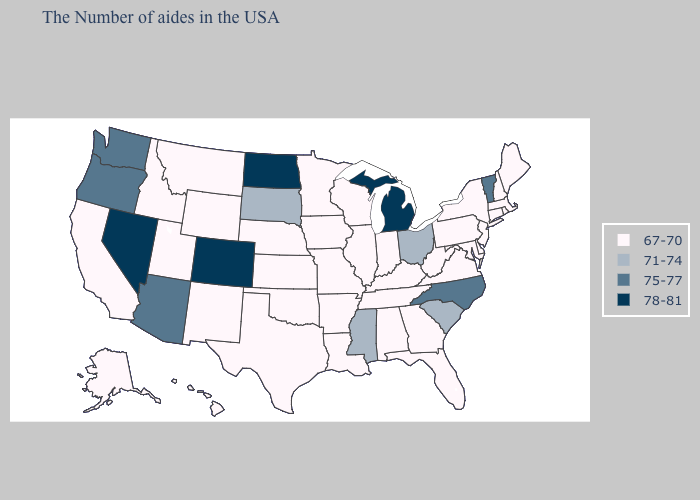What is the value of Alaska?
Short answer required. 67-70. Does Oregon have the lowest value in the West?
Keep it brief. No. Does the first symbol in the legend represent the smallest category?
Short answer required. Yes. Which states hav the highest value in the West?
Write a very short answer. Colorado, Nevada. Among the states that border New Mexico , does Arizona have the highest value?
Be succinct. No. Which states have the lowest value in the USA?
Answer briefly. Maine, Massachusetts, Rhode Island, New Hampshire, Connecticut, New York, New Jersey, Delaware, Maryland, Pennsylvania, Virginia, West Virginia, Florida, Georgia, Kentucky, Indiana, Alabama, Tennessee, Wisconsin, Illinois, Louisiana, Missouri, Arkansas, Minnesota, Iowa, Kansas, Nebraska, Oklahoma, Texas, Wyoming, New Mexico, Utah, Montana, Idaho, California, Alaska, Hawaii. What is the lowest value in the South?
Answer briefly. 67-70. Does North Carolina have the lowest value in the USA?
Quick response, please. No. Does Texas have a higher value than Mississippi?
Concise answer only. No. What is the value of Rhode Island?
Quick response, please. 67-70. What is the value of Arizona?
Concise answer only. 75-77. What is the value of Utah?
Write a very short answer. 67-70. Among the states that border Washington , which have the lowest value?
Answer briefly. Idaho. Among the states that border Texas , which have the lowest value?
Write a very short answer. Louisiana, Arkansas, Oklahoma, New Mexico. Which states have the lowest value in the Northeast?
Write a very short answer. Maine, Massachusetts, Rhode Island, New Hampshire, Connecticut, New York, New Jersey, Pennsylvania. 